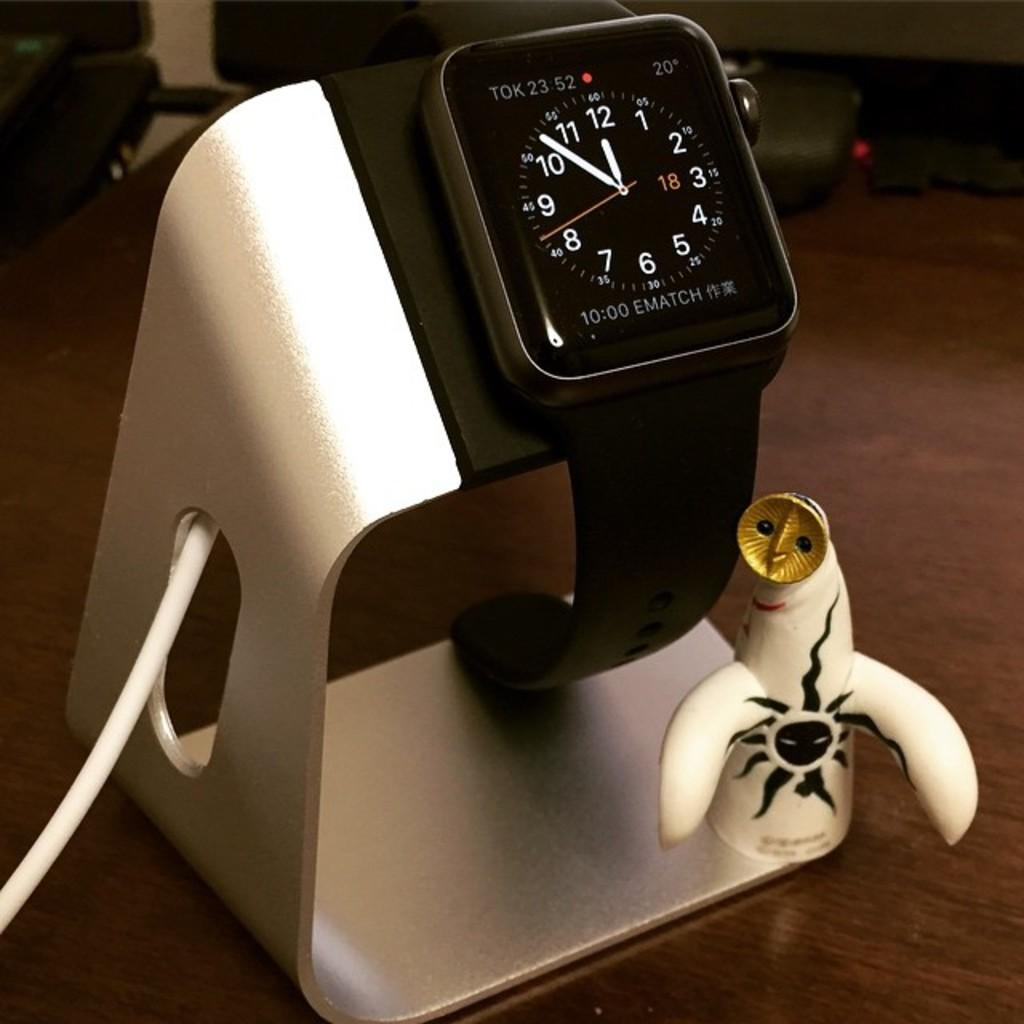<image>
Relay a brief, clear account of the picture shown. A watch is resting on a charger and it says it is it 23:52 